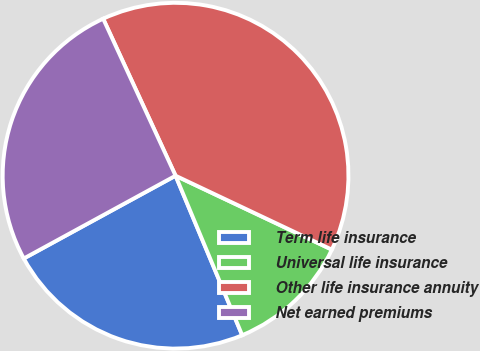Convert chart. <chart><loc_0><loc_0><loc_500><loc_500><pie_chart><fcel>Term life insurance<fcel>Universal life insurance<fcel>Other life insurance annuity<fcel>Net earned premiums<nl><fcel>23.35%<fcel>11.67%<fcel>38.91%<fcel>26.07%<nl></chart> 